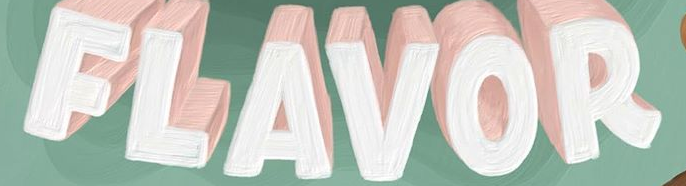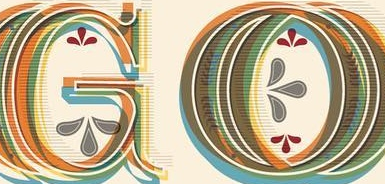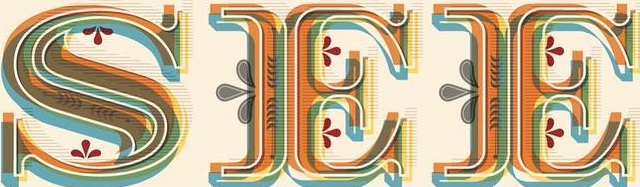Transcribe the words shown in these images in order, separated by a semicolon. FLAVOR; GO; SEE 